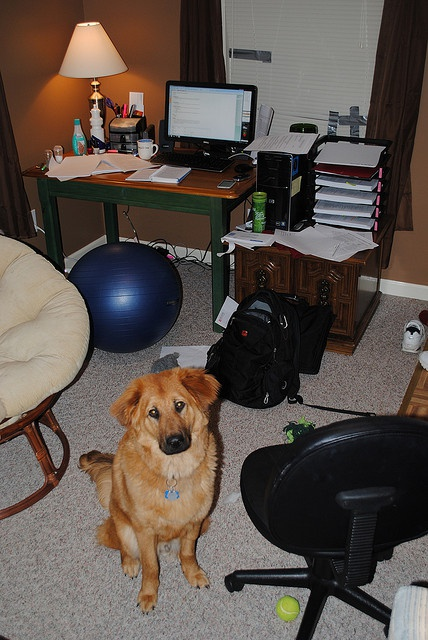Describe the objects in this image and their specific colors. I can see chair in black and gray tones, dog in black, gray, tan, brown, and maroon tones, chair in black, darkgray, gray, and maroon tones, backpack in black, gray, darkgray, and maroon tones, and sports ball in black, navy, darkblue, and gray tones in this image. 